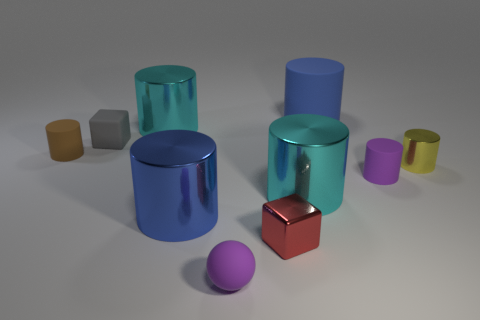There is a thing that is the same color as the ball; what is its shape?
Your response must be concise. Cylinder. What color is the ball that is the same size as the red cube?
Your answer should be very brief. Purple. How many things are either metallic cylinders that are behind the red metal cube or tiny purple matte cylinders?
Offer a terse response. 5. There is a rubber cylinder that is behind the yellow metallic thing and right of the gray object; what size is it?
Your response must be concise. Large. What size is the matte cylinder that is the same color as the sphere?
Provide a short and direct response. Small. How many other objects are the same size as the gray matte thing?
Keep it short and to the point. 5. There is a tiny thing behind the small cylinder left of the large shiny cylinder that is behind the brown thing; what color is it?
Your answer should be very brief. Gray. What is the shape of the large object that is behind the tiny gray rubber object and in front of the large rubber cylinder?
Offer a very short reply. Cylinder. How many other objects are the same shape as the red thing?
Provide a succinct answer. 1. What is the shape of the small purple object that is to the left of the large blue thing behind the cyan thing that is to the left of the ball?
Offer a very short reply. Sphere. 